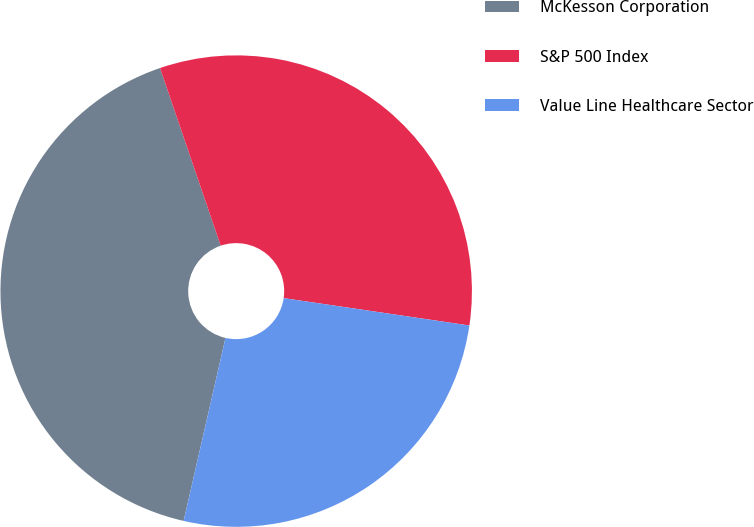Convert chart. <chart><loc_0><loc_0><loc_500><loc_500><pie_chart><fcel>McKesson Corporation<fcel>S&P 500 Index<fcel>Value Line Healthcare Sector<nl><fcel>41.19%<fcel>32.57%<fcel>26.25%<nl></chart> 